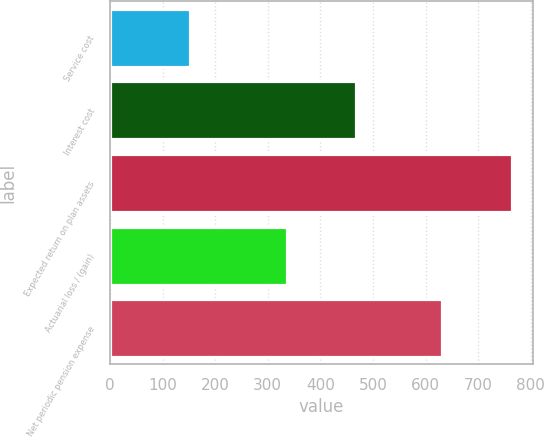<chart> <loc_0><loc_0><loc_500><loc_500><bar_chart><fcel>Service cost<fcel>Interest cost<fcel>Expected return on plan assets<fcel>Actuarial loss / (gain)<fcel>Net periodic pension expense<nl><fcel>153<fcel>467<fcel>765<fcel>337<fcel>632<nl></chart> 